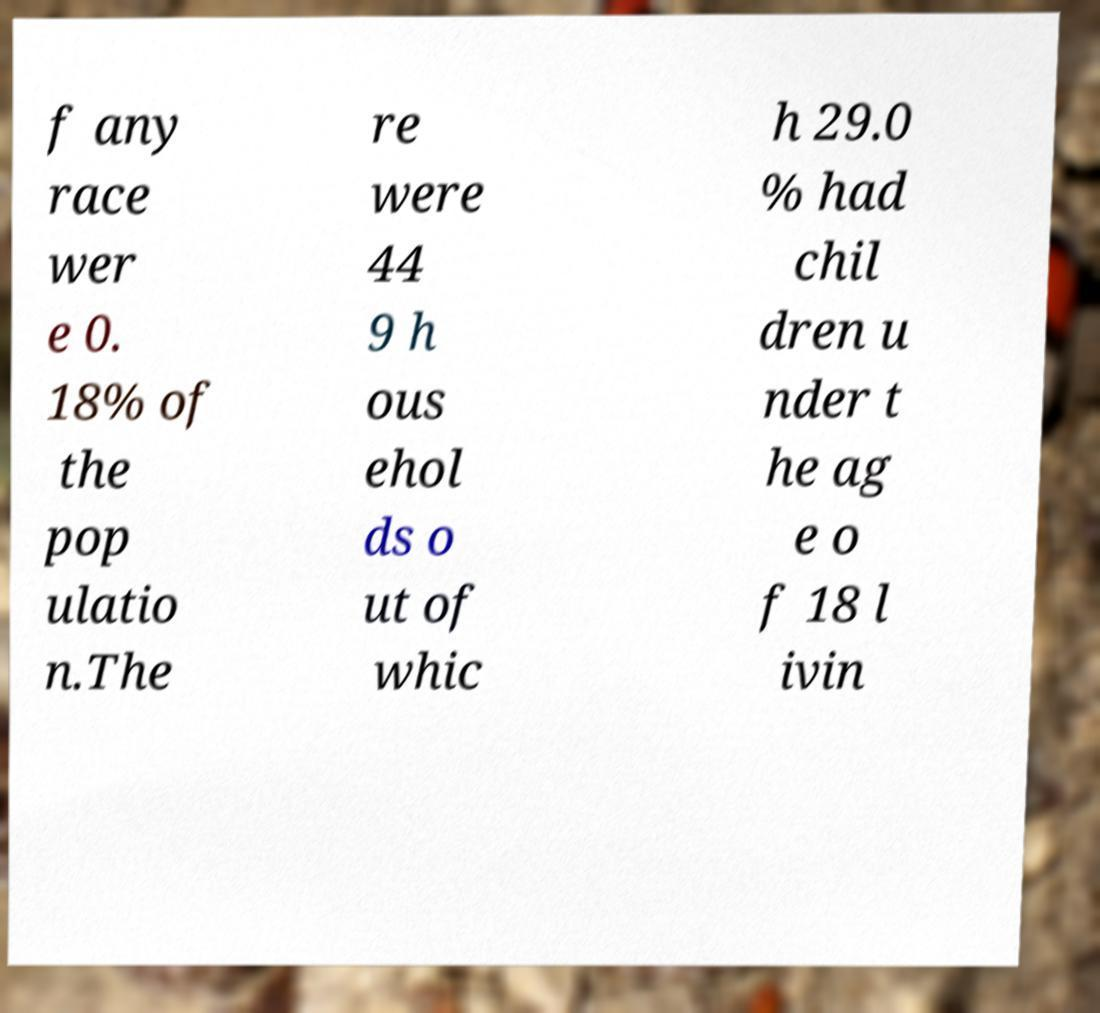For documentation purposes, I need the text within this image transcribed. Could you provide that? f any race wer e 0. 18% of the pop ulatio n.The re were 44 9 h ous ehol ds o ut of whic h 29.0 % had chil dren u nder t he ag e o f 18 l ivin 